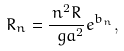Convert formula to latex. <formula><loc_0><loc_0><loc_500><loc_500>R _ { n } = \frac { n ^ { 2 } R } { \ g a ^ { 2 } } e ^ { b _ { n } } ,</formula> 